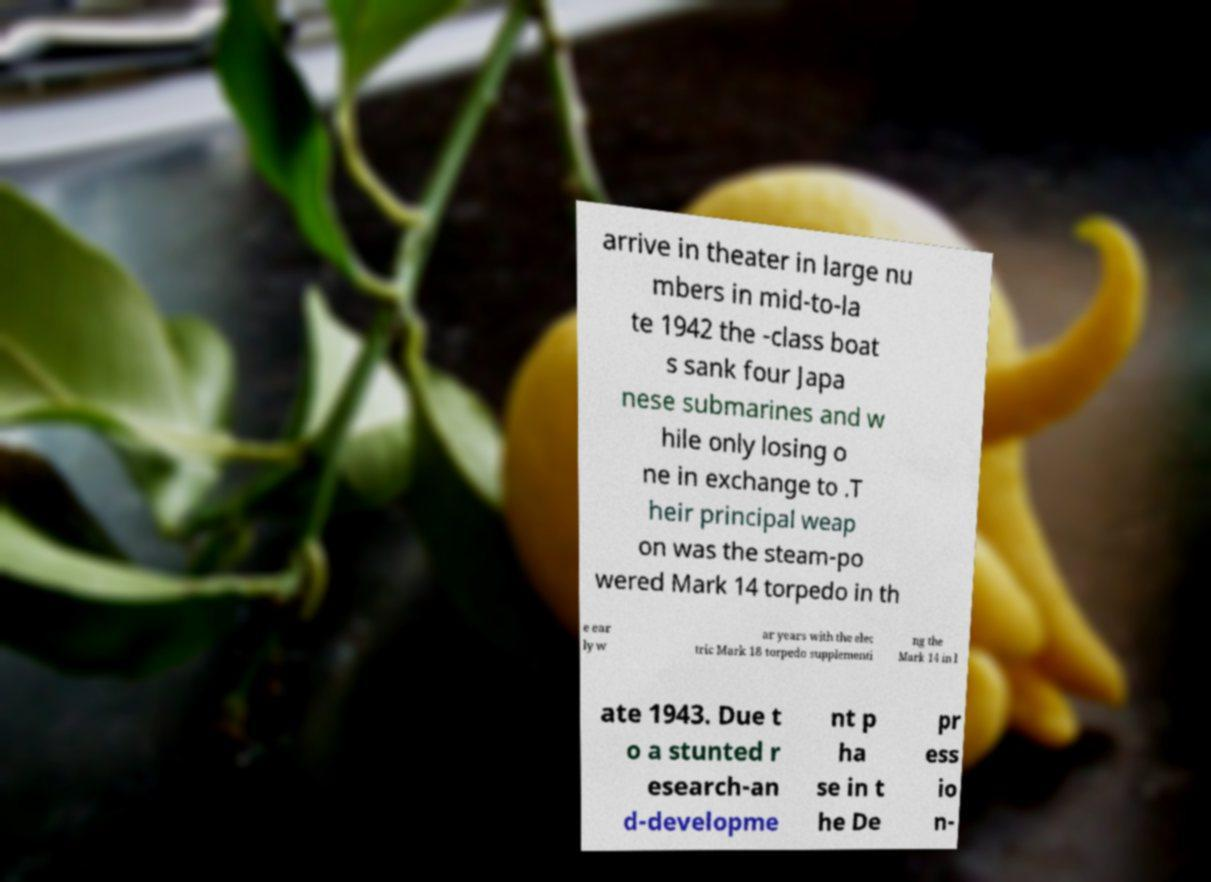Can you accurately transcribe the text from the provided image for me? arrive in theater in large nu mbers in mid-to-la te 1942 the -class boat s sank four Japa nese submarines and w hile only losing o ne in exchange to .T heir principal weap on was the steam-po wered Mark 14 torpedo in th e ear ly w ar years with the elec tric Mark 18 torpedo supplementi ng the Mark 14 in l ate 1943. Due t o a stunted r esearch-an d-developme nt p ha se in t he De pr ess io n- 